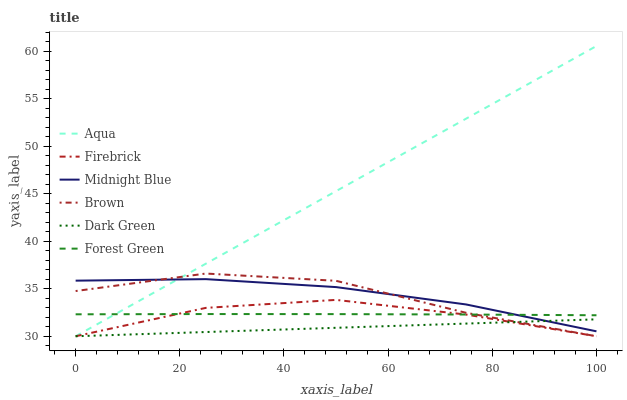Does Dark Green have the minimum area under the curve?
Answer yes or no. Yes. Does Aqua have the maximum area under the curve?
Answer yes or no. Yes. Does Midnight Blue have the minimum area under the curve?
Answer yes or no. No. Does Midnight Blue have the maximum area under the curve?
Answer yes or no. No. Is Dark Green the smoothest?
Answer yes or no. Yes. Is Brown the roughest?
Answer yes or no. Yes. Is Midnight Blue the smoothest?
Answer yes or no. No. Is Midnight Blue the roughest?
Answer yes or no. No. Does Midnight Blue have the lowest value?
Answer yes or no. No. Does Midnight Blue have the highest value?
Answer yes or no. No. Is Dark Green less than Forest Green?
Answer yes or no. Yes. Is Forest Green greater than Dark Green?
Answer yes or no. Yes. Does Dark Green intersect Forest Green?
Answer yes or no. No. 